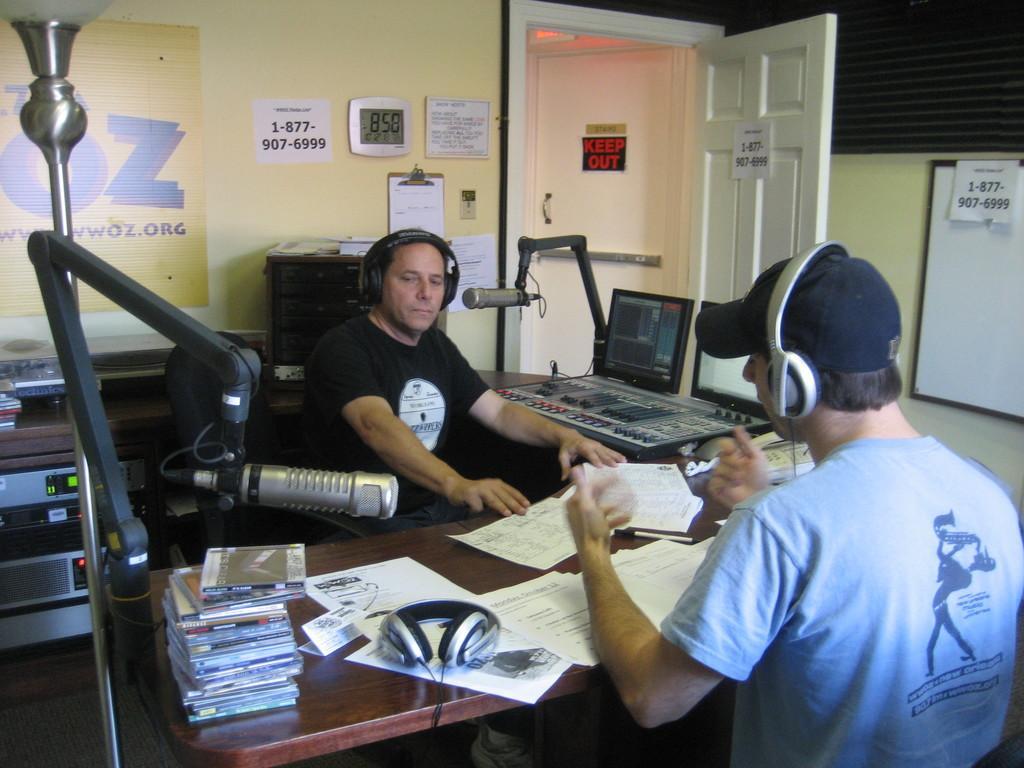Could you give a brief overview of what you see in this image? Two people are sitting on the chairs wearing headphones in front of a desk where cd players and papers are on it, two microphones are there behind them there is a wall with some papers sticked on it and a shelf and a carpet is present and a door is present. 